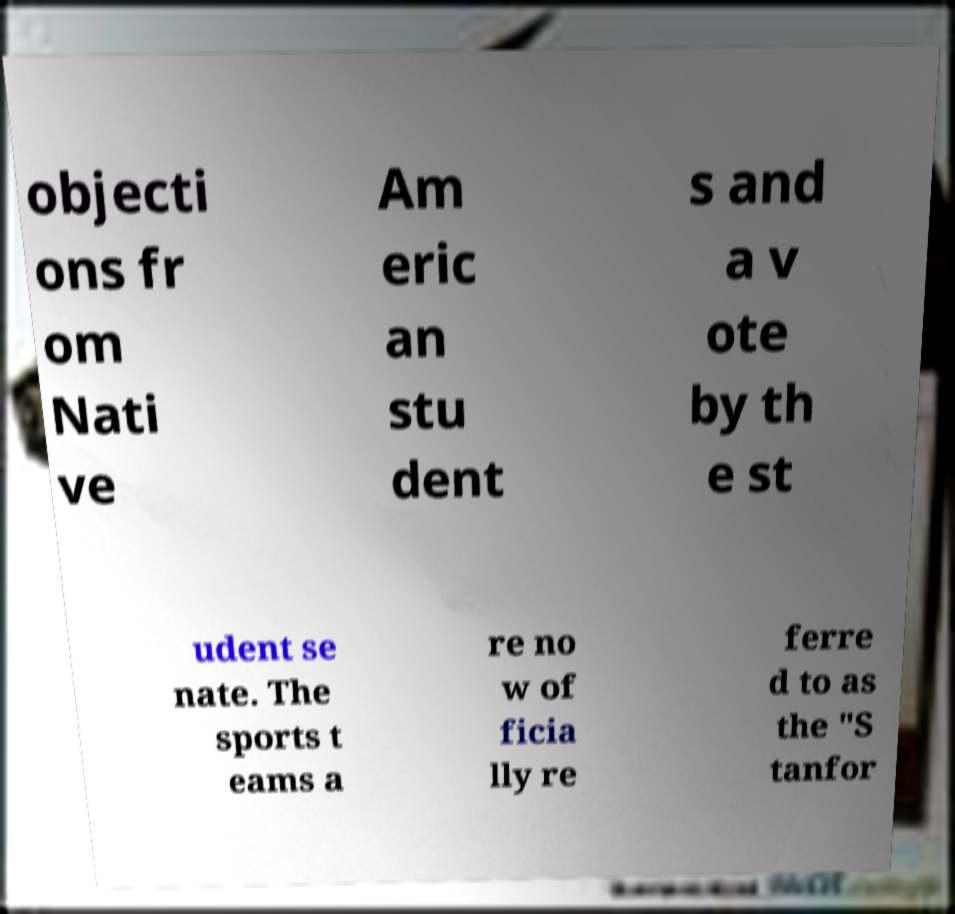Could you assist in decoding the text presented in this image and type it out clearly? objecti ons fr om Nati ve Am eric an stu dent s and a v ote by th e st udent se nate. The sports t eams a re no w of ficia lly re ferre d to as the "S tanfor 